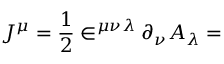Convert formula to latex. <formula><loc_0><loc_0><loc_500><loc_500>J ^ { \mu } = \frac { 1 } { 2 } \in ^ { \mu \nu \lambda } \partial _ { \nu } A _ { \lambda } =</formula> 